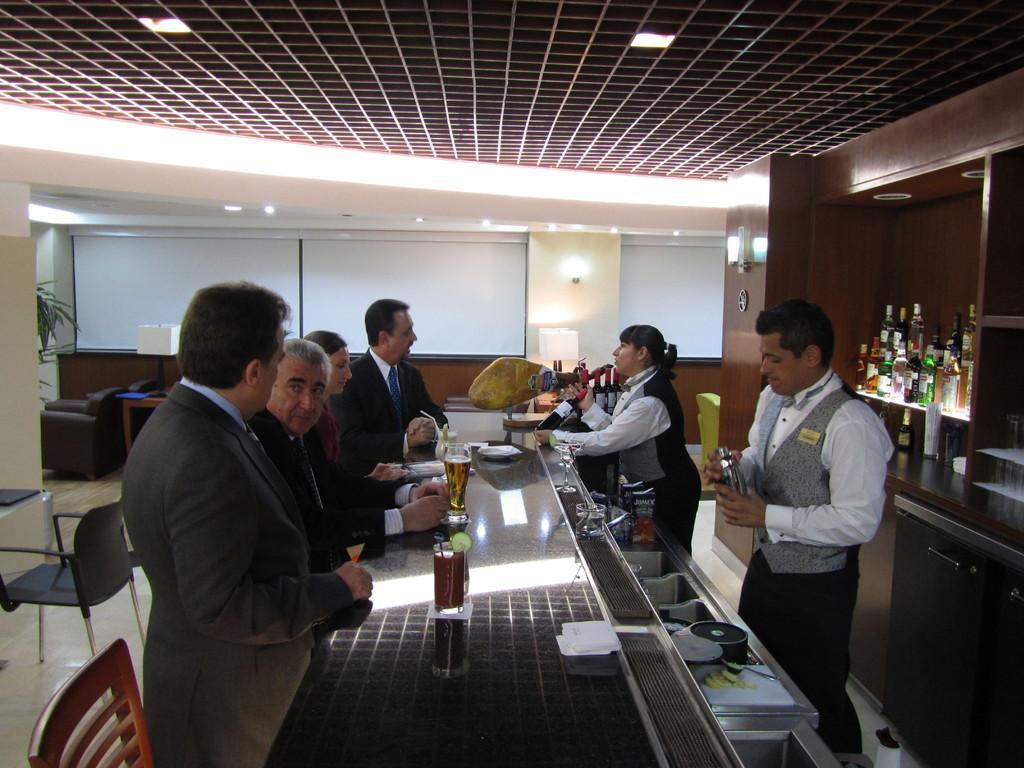In one or two sentences, can you explain what this image depicts? This is an inside view. Here I can see few people standing around the table. On the table I can see few wine glasses. On the right side there is a rack which is filled with the bottles. On the left side there are some chairs. In the background, I can see the wall. 